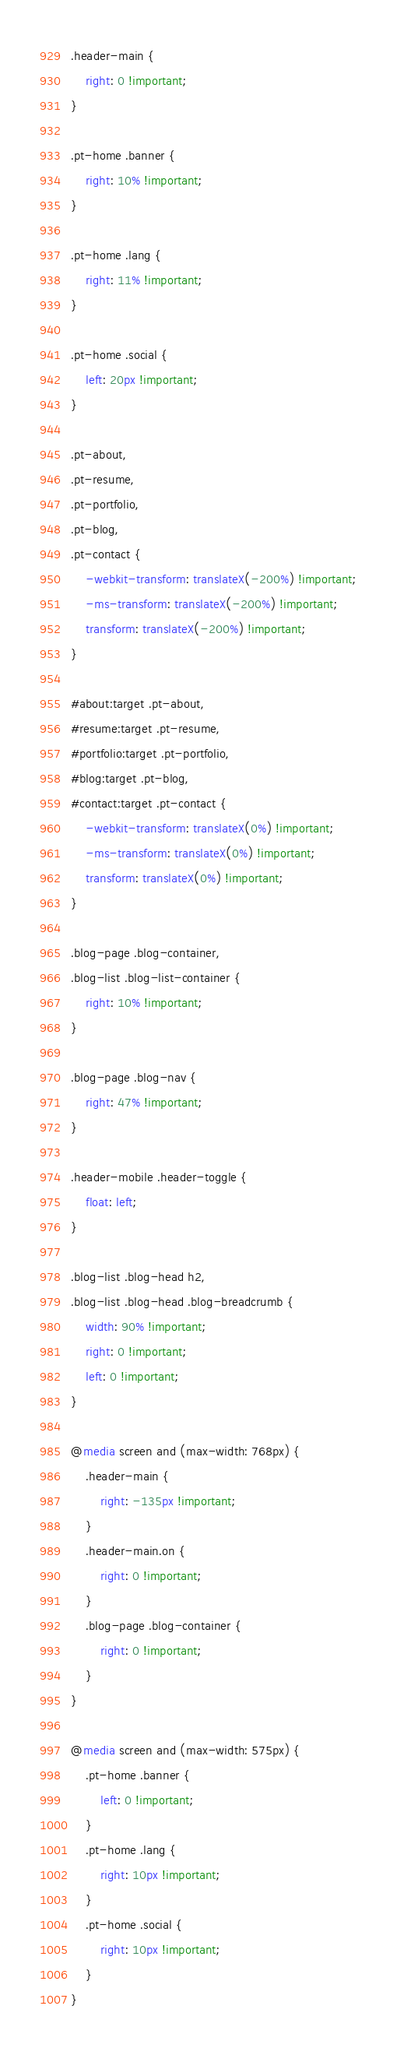Convert code to text. <code><loc_0><loc_0><loc_500><loc_500><_CSS_>.header-main {
	right: 0 !important;
}

.pt-home .banner {
	right: 10% !important;
}

.pt-home .lang {
	right: 11% !important;	
}

.pt-home .social {
	left: 20px !important;	
}

.pt-about, 
.pt-resume, 
.pt-portfolio, 
.pt-blog,
.pt-contact {
	-webkit-transform: translateX(-200%) !important;
	-ms-transform: translateX(-200%) !important;
	transform: translateX(-200%) !important;
}

#about:target .pt-about,
#resume:target .pt-resume,
#portfolio:target .pt-portfolio,
#blog:target .pt-blog,
#contact:target .pt-contact {
	-webkit-transform: translateX(0%) !important;
	-ms-transform: translateX(0%) !important;
	transform: translateX(0%) !important;
}

.blog-page .blog-container,
.blog-list .blog-list-container {
    right: 10% !important;
}

.blog-page .blog-nav {
	right: 47% !important;
}

.header-mobile .header-toggle {
	float: left;
}

.blog-list .blog-head h2,
.blog-list .blog-head .blog-breadcrumb {
	width: 90% !important;
    right: 0 !important;
    left: 0 !important;
}

@media screen and (max-width: 768px) {
	.header-main {
		right: -135px !important;
	}
	.header-main.on {
        right: 0 !important;
    }
	.blog-page .blog-container {
		right: 0 !important;
	}
}

@media screen and (max-width: 575px) {
	.pt-home .banner {
		left: 0 !important;
	}
	.pt-home .lang {
		right: 10px !important;	
	}
	.pt-home .social {
		right: 10px !important;	
	}
}</code> 